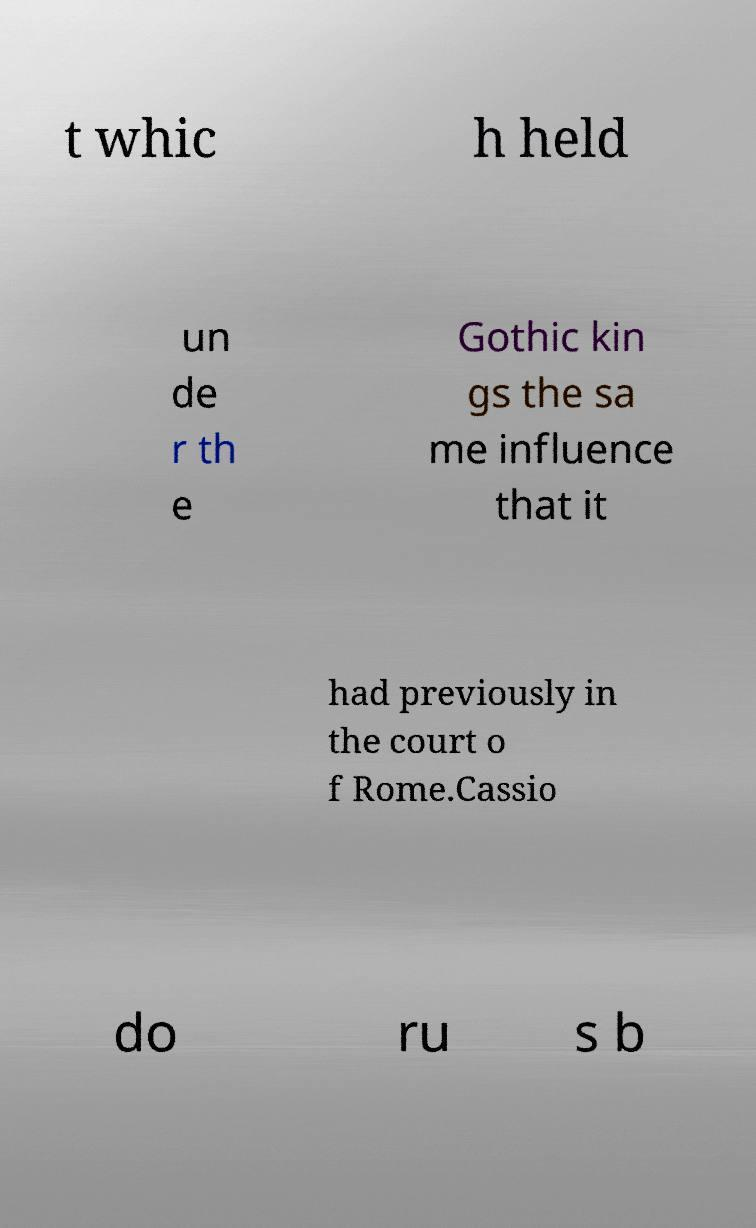Can you accurately transcribe the text from the provided image for me? t whic h held un de r th e Gothic kin gs the sa me influence that it had previously in the court o f Rome.Cassio do ru s b 